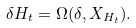Convert formula to latex. <formula><loc_0><loc_0><loc_500><loc_500>\delta H _ { t } = \Omega ( \delta , X _ { H _ { t } } ) .</formula> 